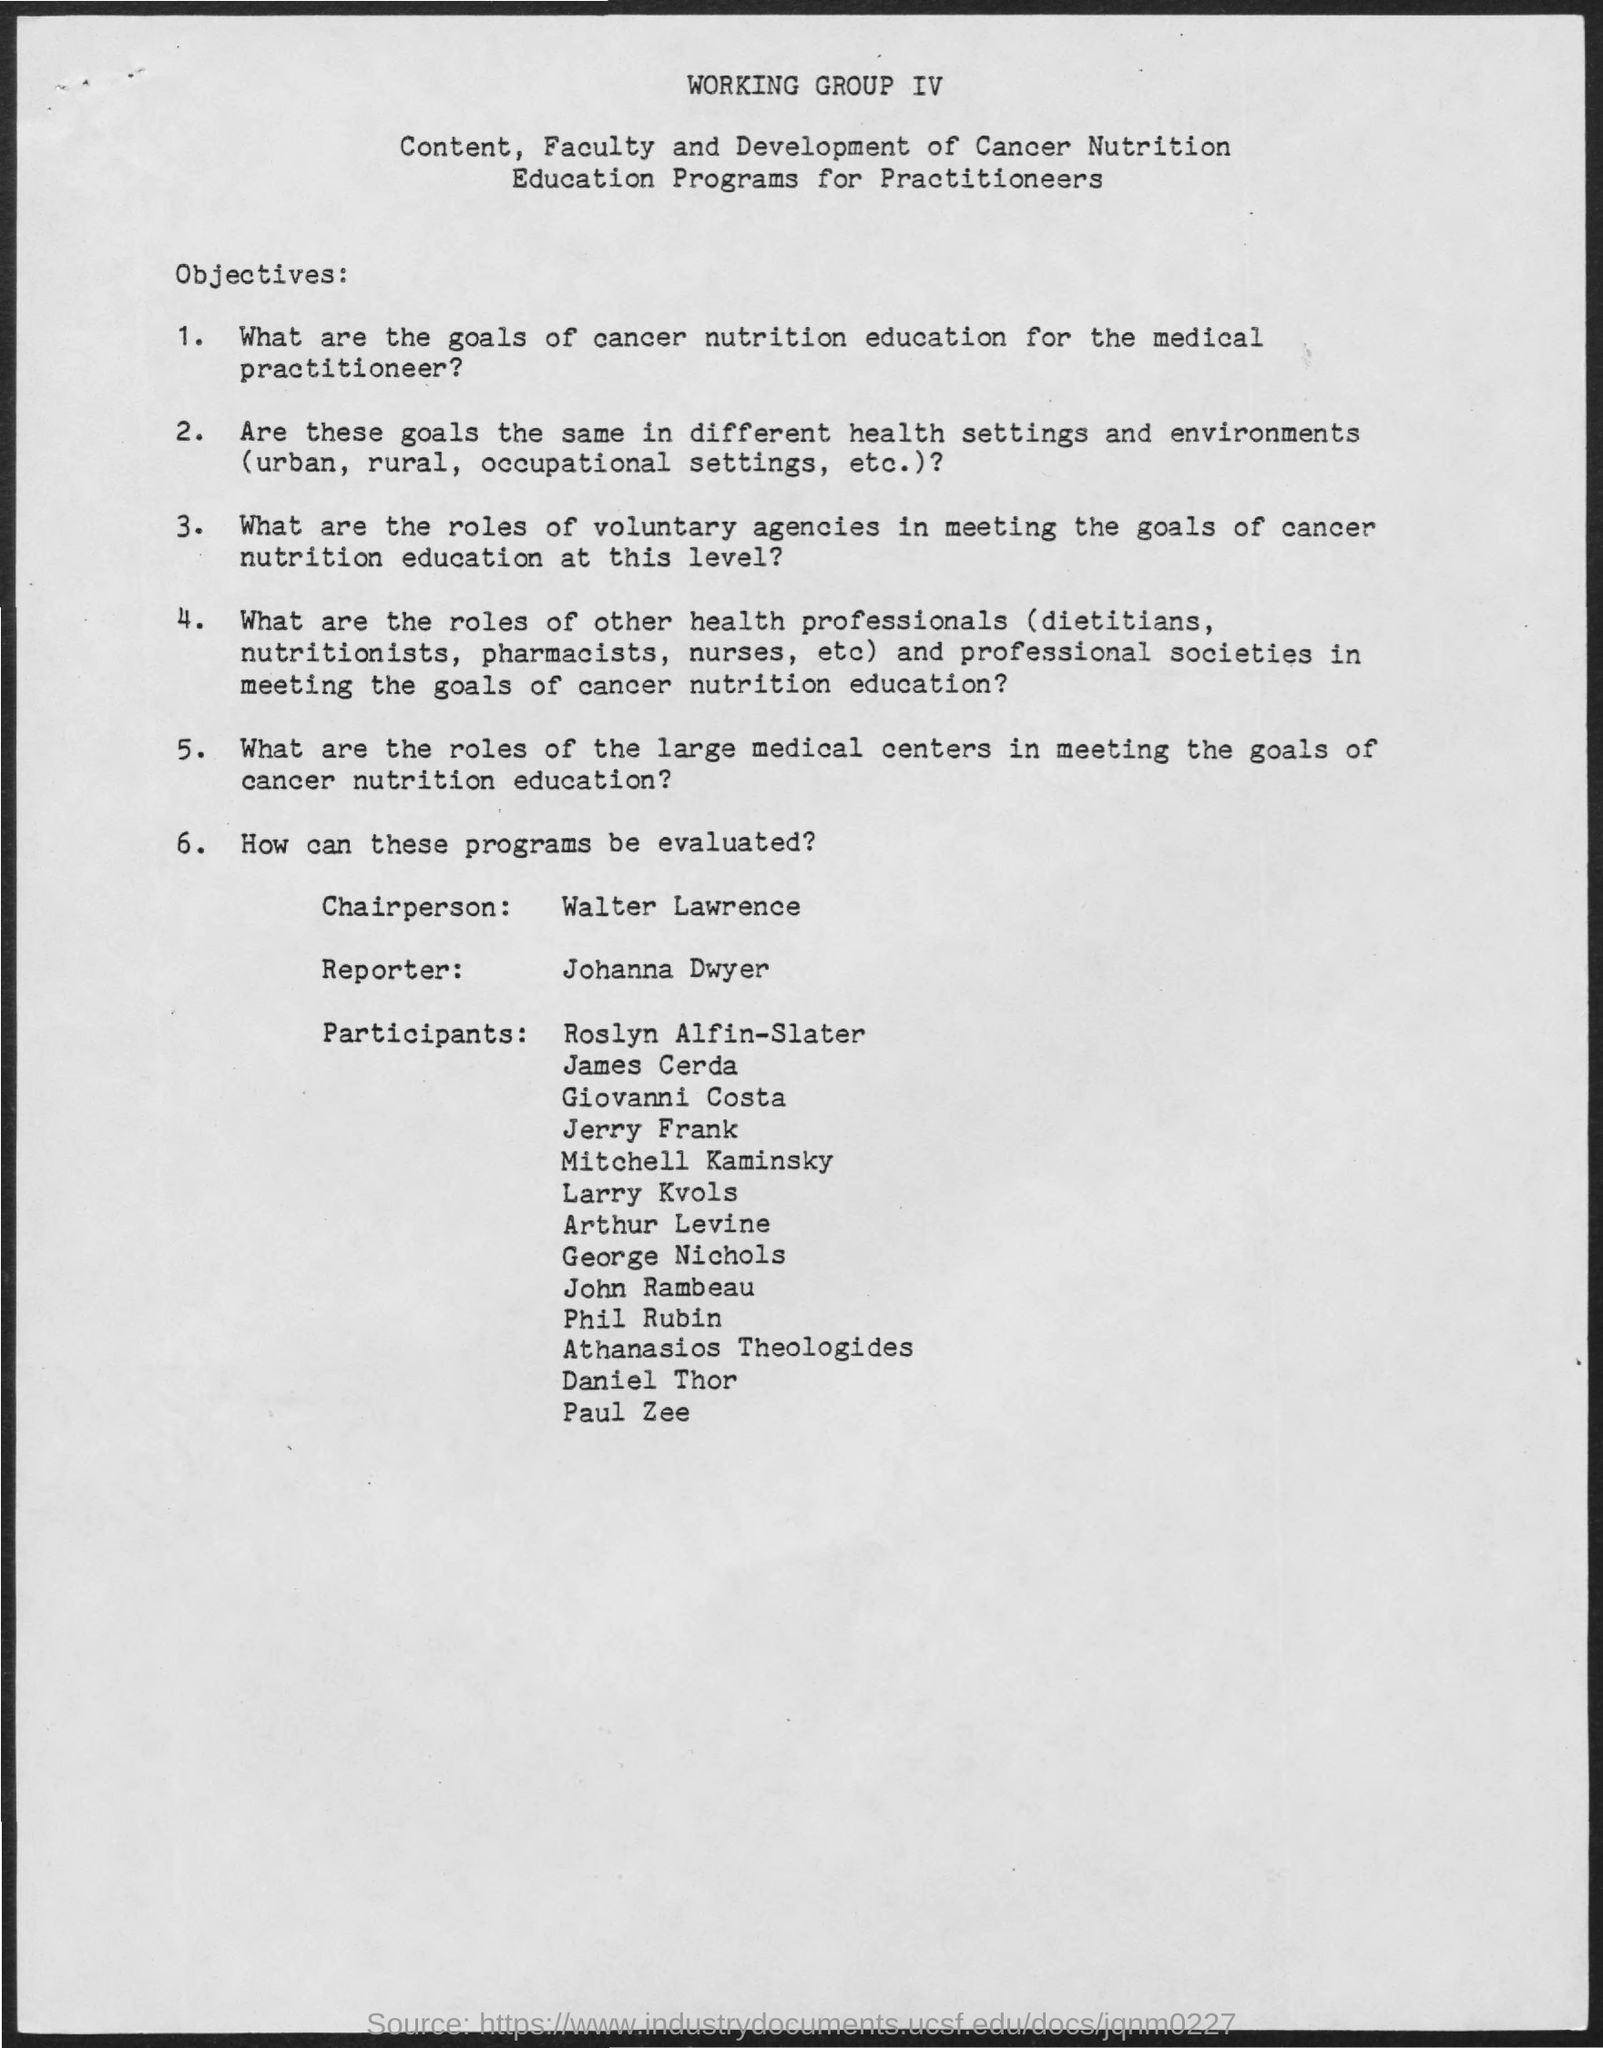Point out several critical features in this image. The reporter's name is Johanna Dwyer. The Chairperson mentioned is Walter Lawrence. 